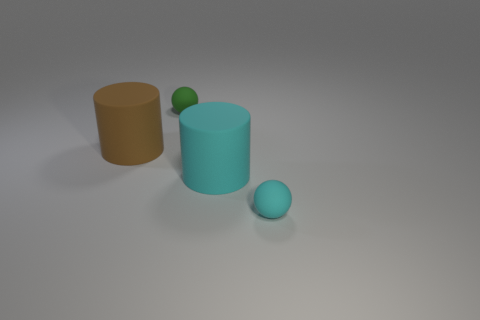Add 1 tiny green rubber objects. How many objects exist? 5 Subtract 1 balls. How many balls are left? 1 Subtract all brown balls. Subtract all cyan blocks. How many balls are left? 2 Subtract all small cyan matte objects. Subtract all green objects. How many objects are left? 2 Add 3 big rubber cylinders. How many big rubber cylinders are left? 5 Add 4 brown shiny things. How many brown shiny things exist? 4 Subtract 1 cyan spheres. How many objects are left? 3 